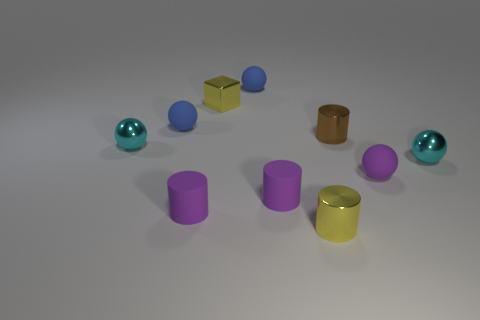Subtract all purple spheres. How many spheres are left? 4 Subtract all purple balls. How many balls are left? 4 Subtract 2 spheres. How many spheres are left? 3 Subtract all gray cylinders. Subtract all purple balls. How many cylinders are left? 4 Subtract all cylinders. How many objects are left? 6 Add 5 tiny shiny balls. How many tiny shiny balls exist? 7 Subtract 0 green blocks. How many objects are left? 10 Subtract all brown metal cubes. Subtract all purple balls. How many objects are left? 9 Add 4 metal balls. How many metal balls are left? 6 